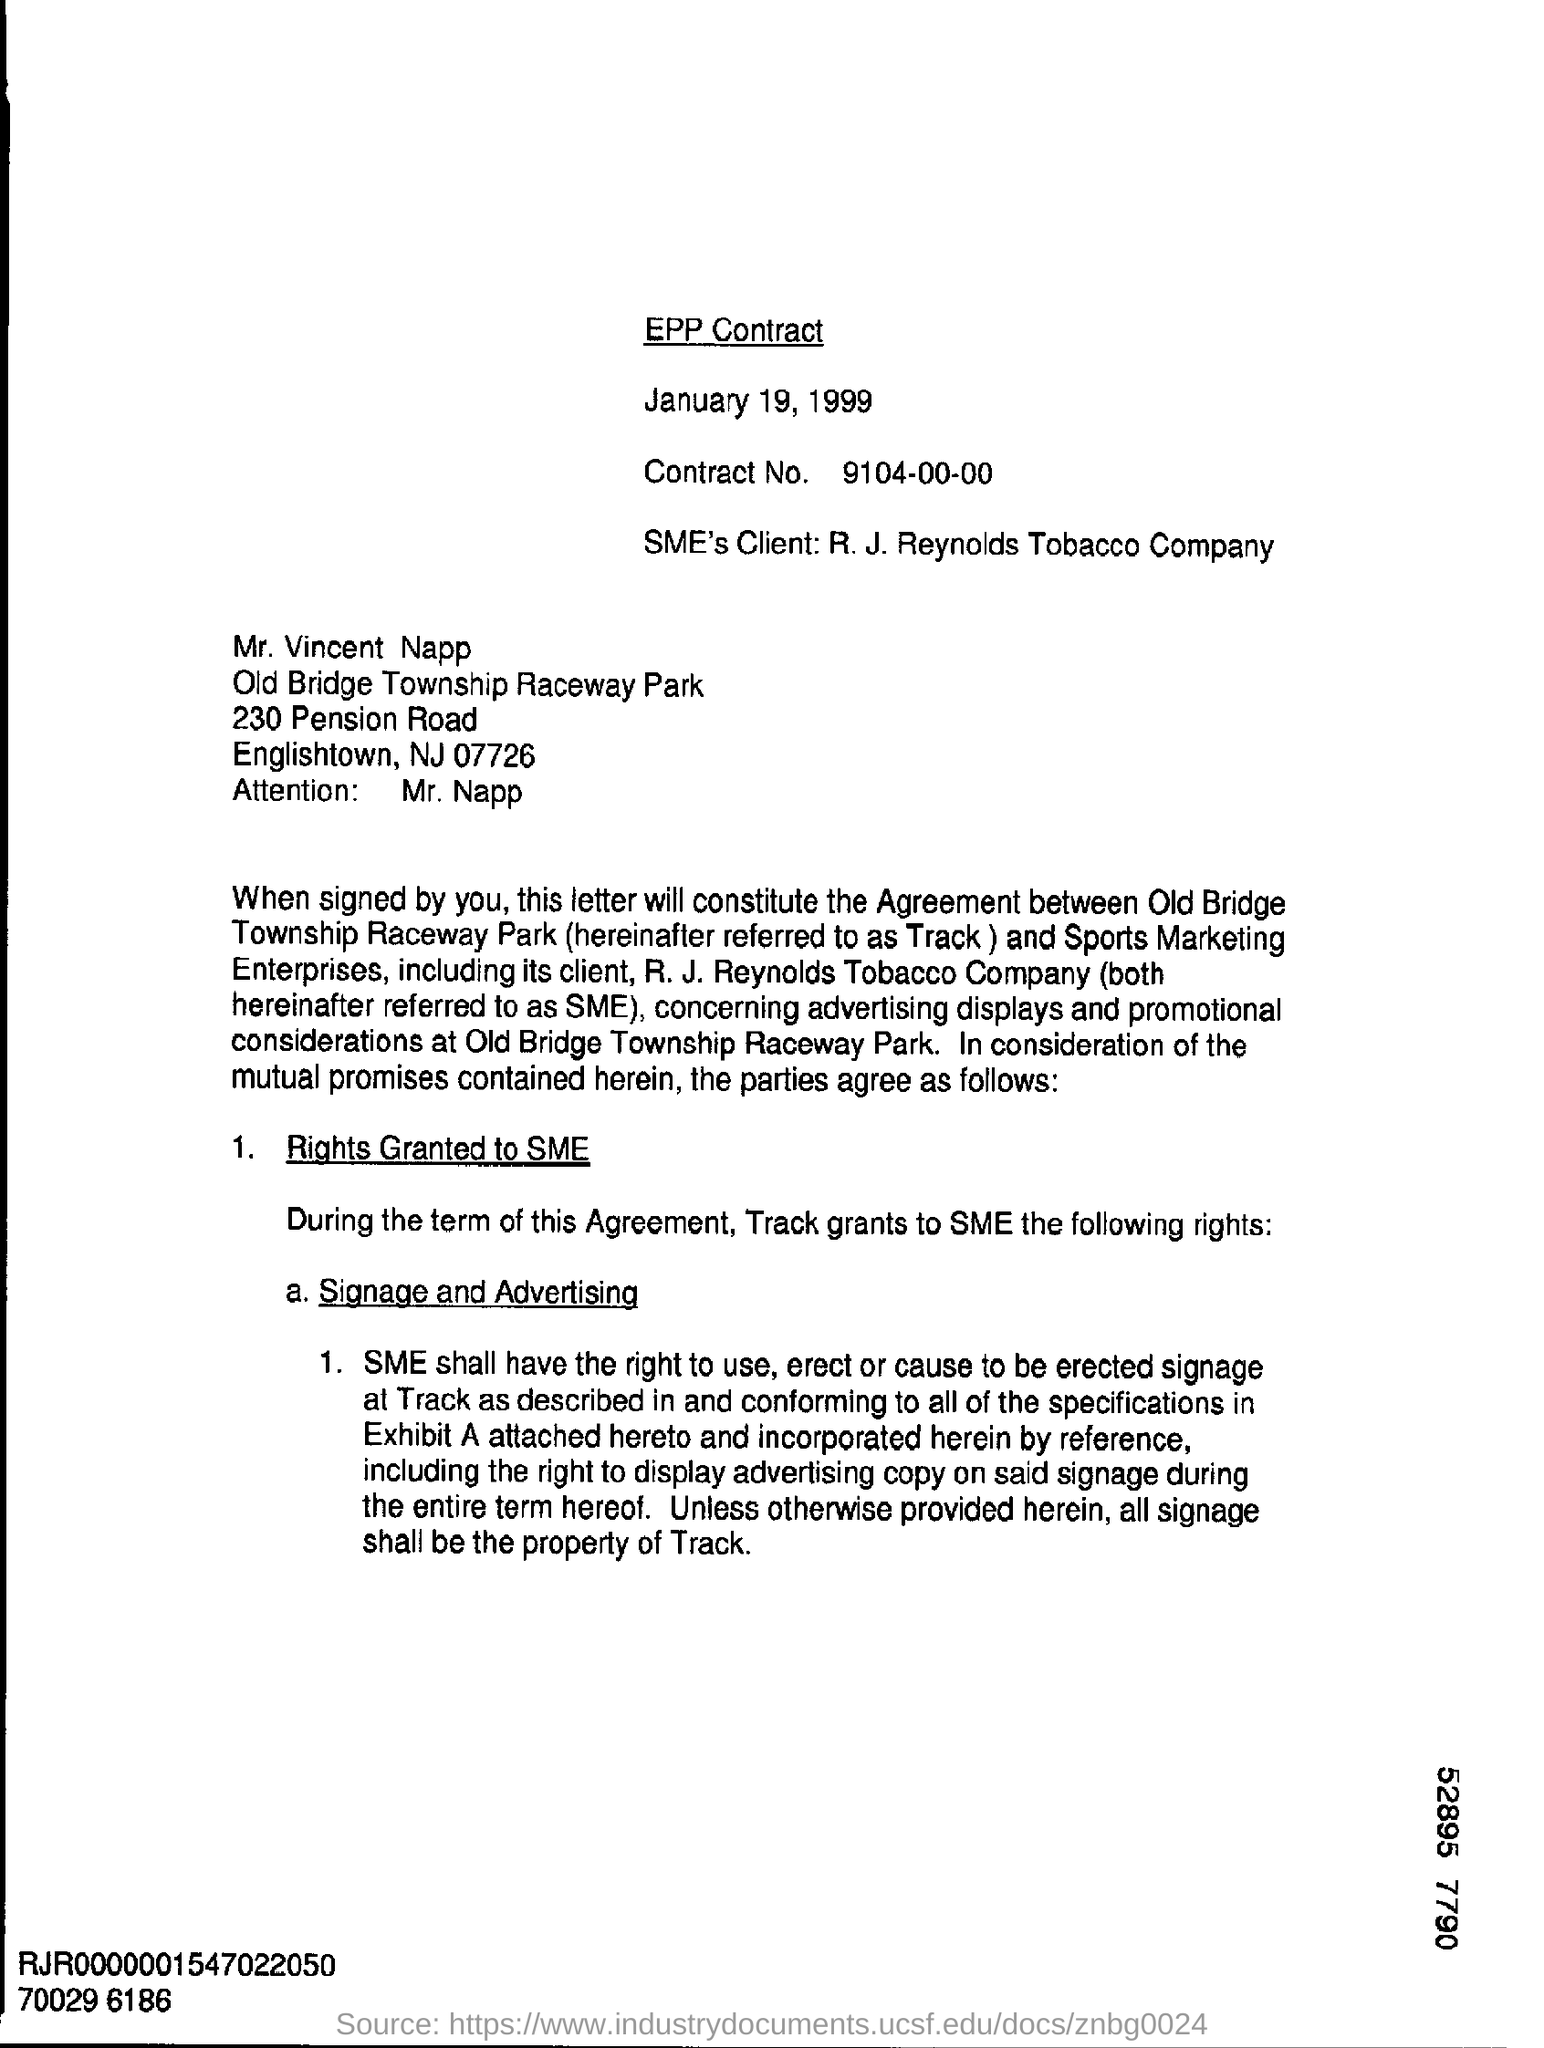What type of contract is mentioned in first line of this document?
Keep it short and to the point. EPP Contract. What is the date of the contract?
Give a very brief answer. January 19, 1999. What is the contract number?
Your response must be concise. 9104-00-00. What SME's client name?
Provide a succinct answer. R.J. Reynolds Tobacco Company. To whom the letter is addressed?
Offer a terse response. Mr. Vincent Napp. What is the name of the road mentioned in this letter?
Your answer should be compact. Pension Road. Whose attention is invited in this letter?
Give a very brief answer. Mr. Napp. Who is refereed as track
Your response must be concise. Old Bridge Township Raceway Park. 